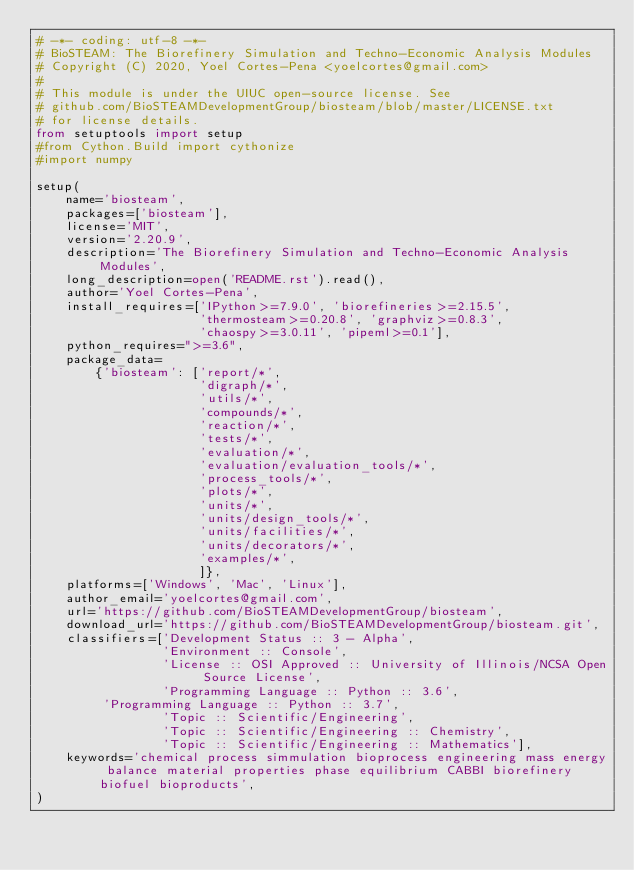Convert code to text. <code><loc_0><loc_0><loc_500><loc_500><_Python_># -*- coding: utf-8 -*-
# BioSTEAM: The Biorefinery Simulation and Techno-Economic Analysis Modules
# Copyright (C) 2020, Yoel Cortes-Pena <yoelcortes@gmail.com>
# 
# This module is under the UIUC open-source license. See 
# github.com/BioSTEAMDevelopmentGroup/biosteam/blob/master/LICENSE.txt
# for license details.
from setuptools import setup
#from Cython.Build import cythonize
#import numpy

setup(
    name='biosteam',
    packages=['biosteam'],
    license='MIT',
    version='2.20.9',
    description='The Biorefinery Simulation and Techno-Economic Analysis Modules',
    long_description=open('README.rst').read(),
    author='Yoel Cortes-Pena',
    install_requires=['IPython>=7.9.0', 'biorefineries>=2.15.5',
                      'thermosteam>=0.20.8', 'graphviz>=0.8.3',
                      'chaospy>=3.0.11', 'pipeml>=0.1'],
    python_requires=">=3.6",
    package_data=
        {'biosteam': ['report/*',
                      'digraph/*',
                      'utils/*',
                      'compounds/*',
                      'reaction/*',
                      'tests/*',
                      'evaluation/*', 
                      'evaluation/evaluation_tools/*',
                      'process_tools/*',
                      'plots/*',
                      'units/*',
                      'units/design_tools/*',
                      'units/facilities/*',
                      'units/decorators/*',
                      'examples/*',
                      ]},
    platforms=['Windows', 'Mac', 'Linux'],
    author_email='yoelcortes@gmail.com',
    url='https://github.com/BioSTEAMDevelopmentGroup/biosteam',
    download_url='https://github.com/BioSTEAMDevelopmentGroup/biosteam.git',
    classifiers=['Development Status :: 3 - Alpha',
                 'Environment :: Console',
                 'License :: OSI Approved :: University of Illinois/NCSA Open Source License',
                 'Programming Language :: Python :: 3.6',
				 'Programming Language :: Python :: 3.7',
                 'Topic :: Scientific/Engineering',
                 'Topic :: Scientific/Engineering :: Chemistry',
                 'Topic :: Scientific/Engineering :: Mathematics'],
    keywords='chemical process simmulation bioprocess engineering mass energy balance material properties phase equilibrium CABBI biorefinery biofuel bioproducts',
)</code> 